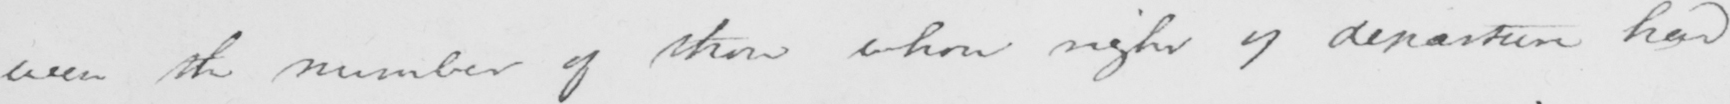What does this handwritten line say? even the number of them whose right of departure had 